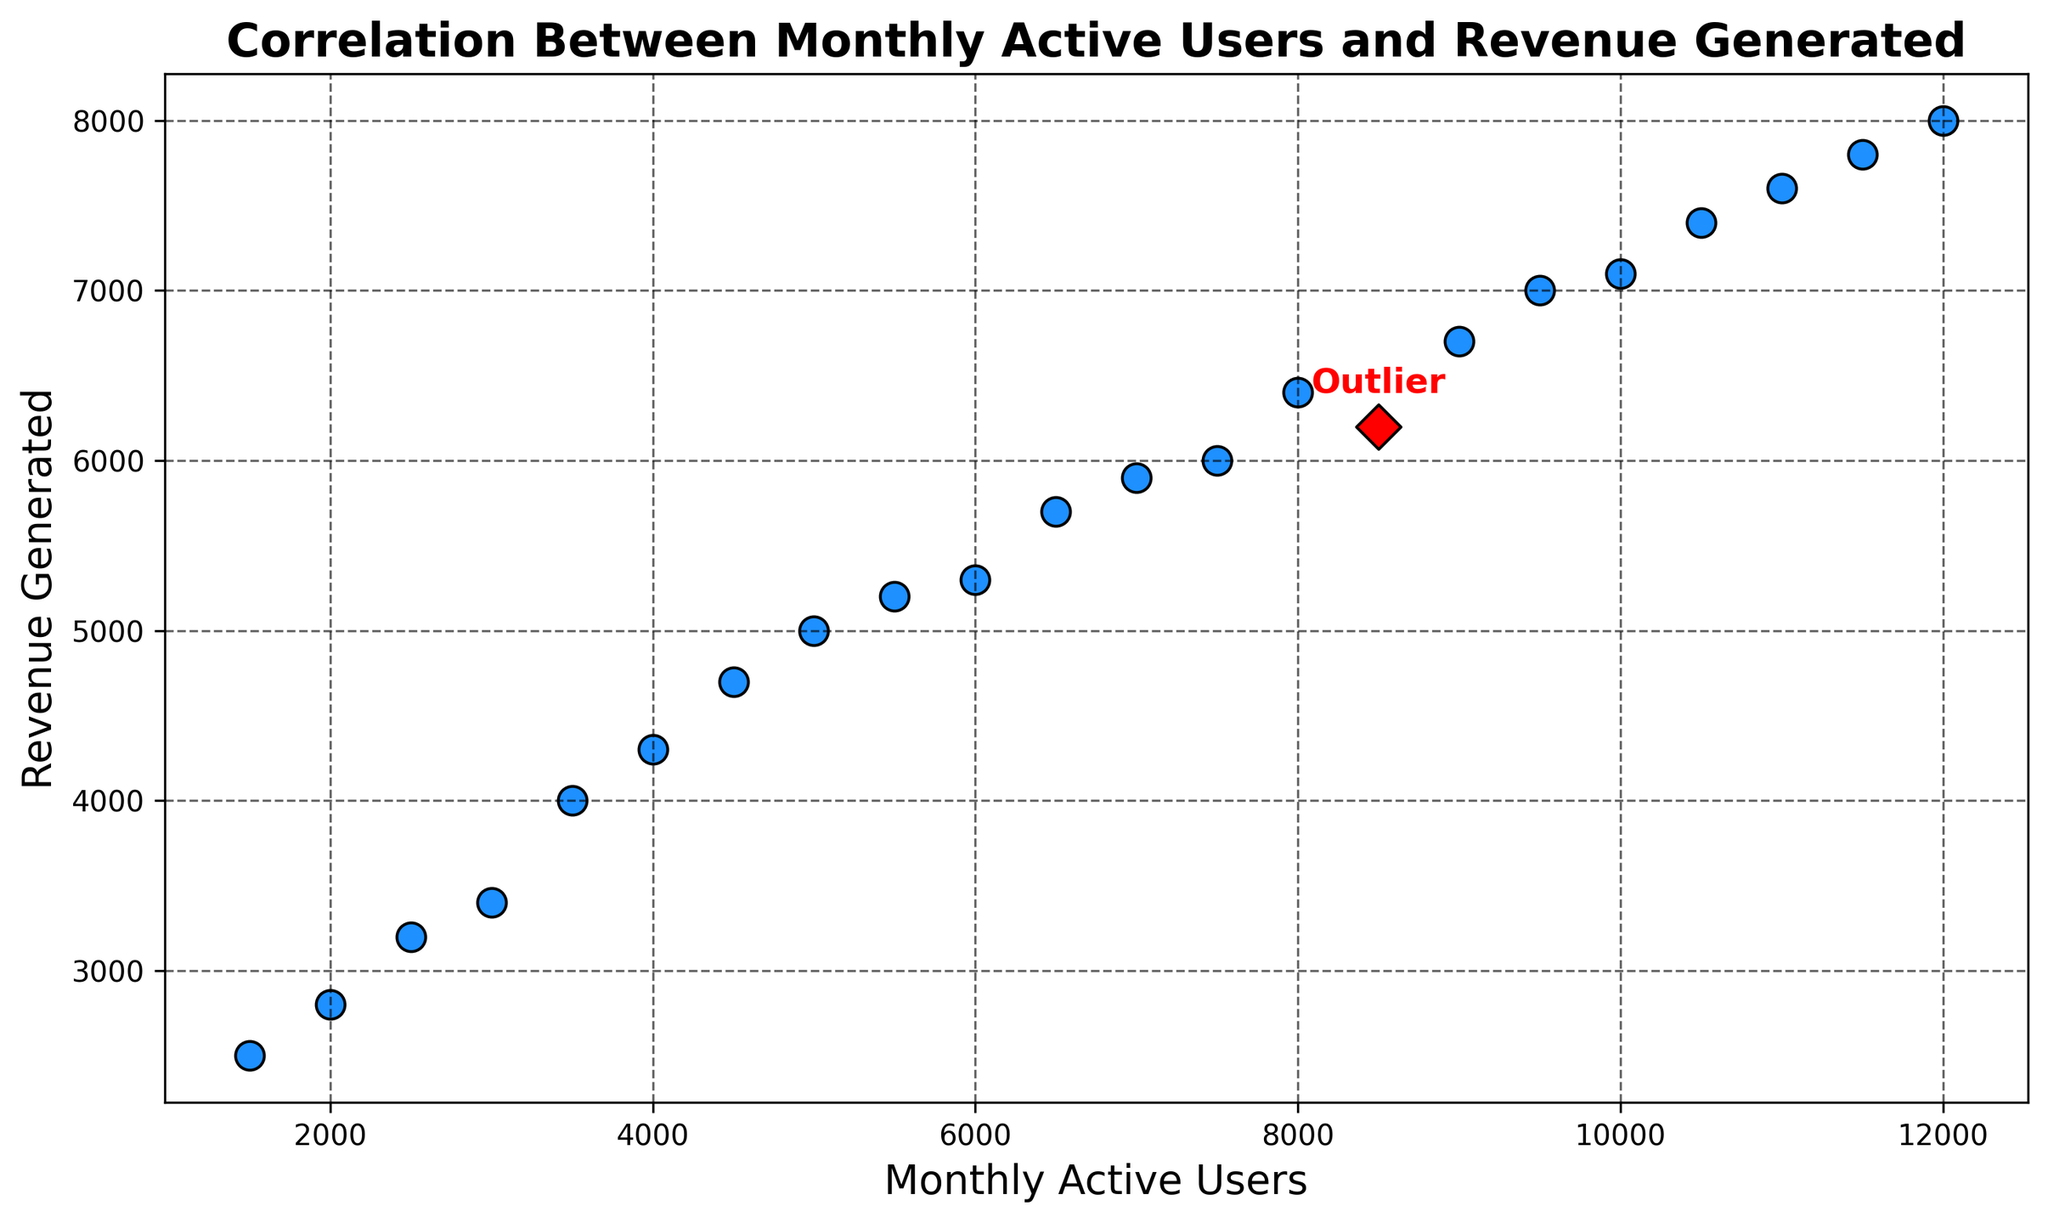How many monthly active users (MAUs) are associated with the outlier revenue point? To find the MAUs for the outlier, look for the point annotated with "Outlier". The annotation is near the MAU of 8500 on the x-axis.
Answer: 8500 MAUs What is the relationship between the number of monthly active users and revenue generated in general? By observing the plot, one can see that as the number of monthly active users increases, the revenue generated also generally increases, indicating a positive correlation.
Answer: Positive correlation Is there a data point with the highest revenue generated, and if so, how many monthly active users does it have? Locate the point that is vertical furthest on the y-axis. The highest revenue is around 8000, corresponding to 12000 MAUs.
Answer: 12000 MAUs Which has greater revenue, the data point with 5000 MAUs or the one with 7000 MAUs? Locate the 5000 MAUs point and the 7000 MAUs point on the plot. The revenue for 5000 MAUs is about 5000, and for 7000 MAUs, it is about 5900, so 7000 MAUs is greater.
Answer: 7000 MAUs What is the revenue range for data points with more than 10000 monthly active users? Identify the points with MAUs greater than 10000. The revenue ranges from 7400 to 8000 for these points.
Answer: 7400 to 8000 Compare the revenue generated for 3500 MAUs and the outlier point. Locate the points for 3500 MAUs and the outlier. The revenue for 3500 MAUs is around 4000, and for the outlier (8500 MAUs) it is around 6200.
Answer: Outlier (8500 MAUs) What is the average revenue generated for data points with less than 6000 MAUs? Identify points less than 6000 MAUs: 1500, 2000, 2500, 3000, 3500, 4000, 4500, 5000, 5500. Their revenues are 2500, 2800, 3200, 3400, 4000, 4300, 4700, 5000, 5200. The average is (2500+2800+3200+3400+4000+4300+4700+5000+5200)/9 = 3900.
Answer: 3900 What trend do you observe between monthly active users and revenue as MAUs approach 10000? As MAUs approach 10000, the revenue continues to increase. However, beyond 10000, the increase in revenue starts to level off.
Answer: Increases and then levels off How do outliers affect the overall trend in this scatter plot? The outlier deviates from the general trend and can skew the perception of the correlation between MAUs and revenue. It appears higher on the revenue scale for given MAUs, indicating anomaly or exceptional performance.
Answer: Skew the perception of correlation 